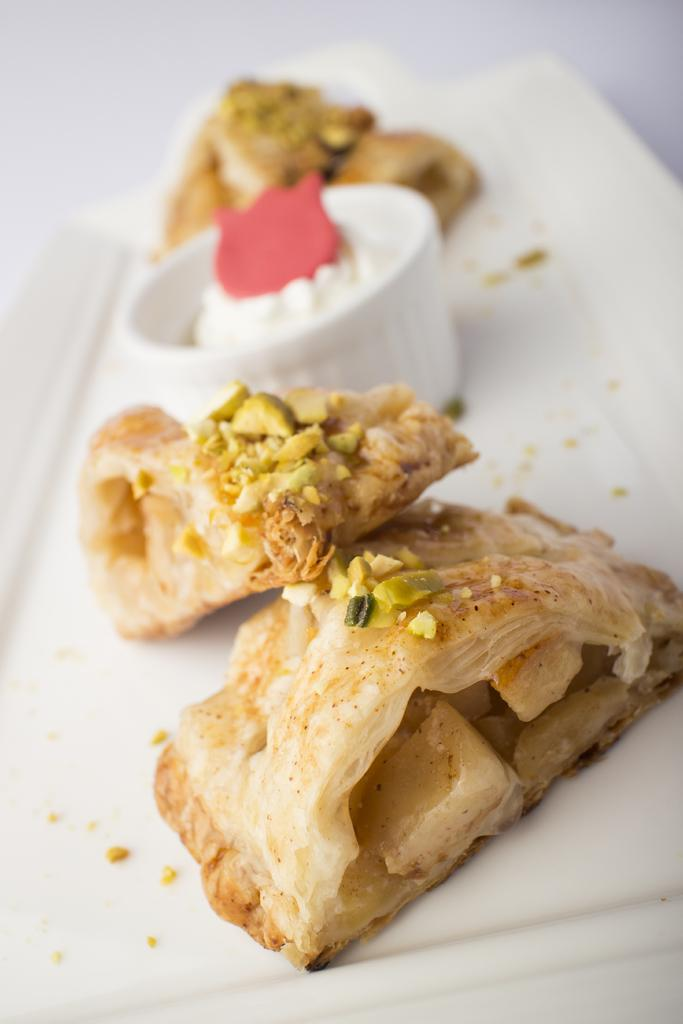What object is present in the image that can hold items? There is a tray in the image. What color is the tray? The tray is white in color. What can be found on the tray? There are food items on the tray. What grade did the son receive on his lace project in the image? There is no mention of a son, a grade, or a lace project in the image. 